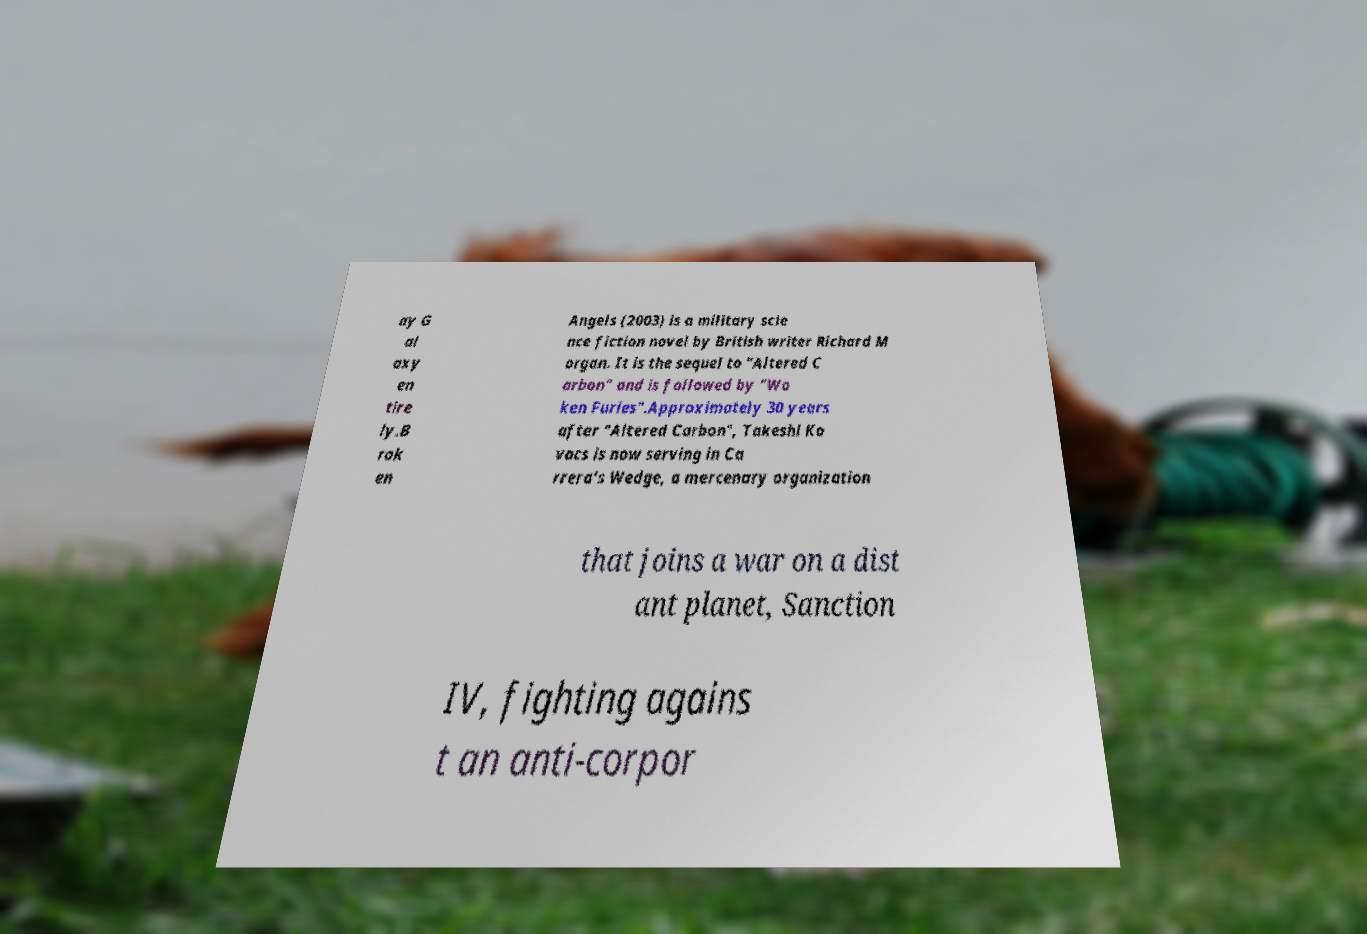Please read and relay the text visible in this image. What does it say? ay G al axy en tire ly.B rok en Angels (2003) is a military scie nce fiction novel by British writer Richard M organ. It is the sequel to "Altered C arbon" and is followed by "Wo ken Furies".Approximately 30 years after "Altered Carbon", Takeshi Ko vacs is now serving in Ca rrera's Wedge, a mercenary organization that joins a war on a dist ant planet, Sanction IV, fighting agains t an anti-corpor 